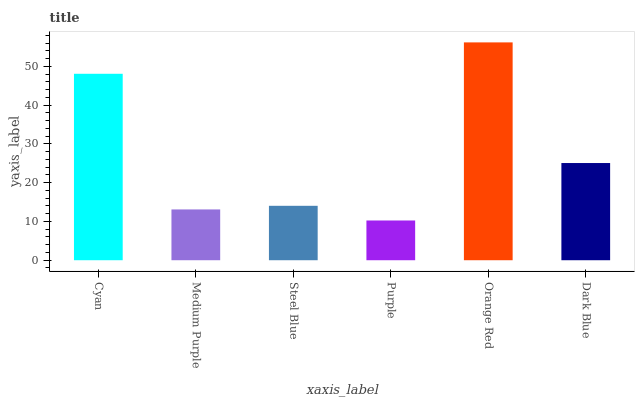Is Medium Purple the minimum?
Answer yes or no. No. Is Medium Purple the maximum?
Answer yes or no. No. Is Cyan greater than Medium Purple?
Answer yes or no. Yes. Is Medium Purple less than Cyan?
Answer yes or no. Yes. Is Medium Purple greater than Cyan?
Answer yes or no. No. Is Cyan less than Medium Purple?
Answer yes or no. No. Is Dark Blue the high median?
Answer yes or no. Yes. Is Steel Blue the low median?
Answer yes or no. Yes. Is Purple the high median?
Answer yes or no. No. Is Purple the low median?
Answer yes or no. No. 